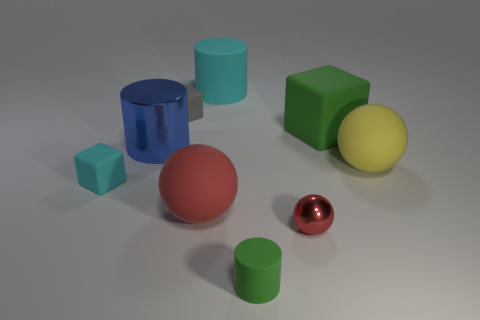Subtract all metal cylinders. How many cylinders are left? 2 Add 1 large blue matte cylinders. How many objects exist? 10 Subtract 3 balls. How many balls are left? 0 Subtract all gray objects. Subtract all blue metal cylinders. How many objects are left? 7 Add 5 small metallic balls. How many small metallic balls are left? 6 Add 1 brown metallic balls. How many brown metallic balls exist? 1 Subtract all cyan cylinders. How many cylinders are left? 2 Subtract 0 purple cubes. How many objects are left? 9 Subtract all cubes. How many objects are left? 6 Subtract all blue blocks. Subtract all blue cylinders. How many blocks are left? 3 